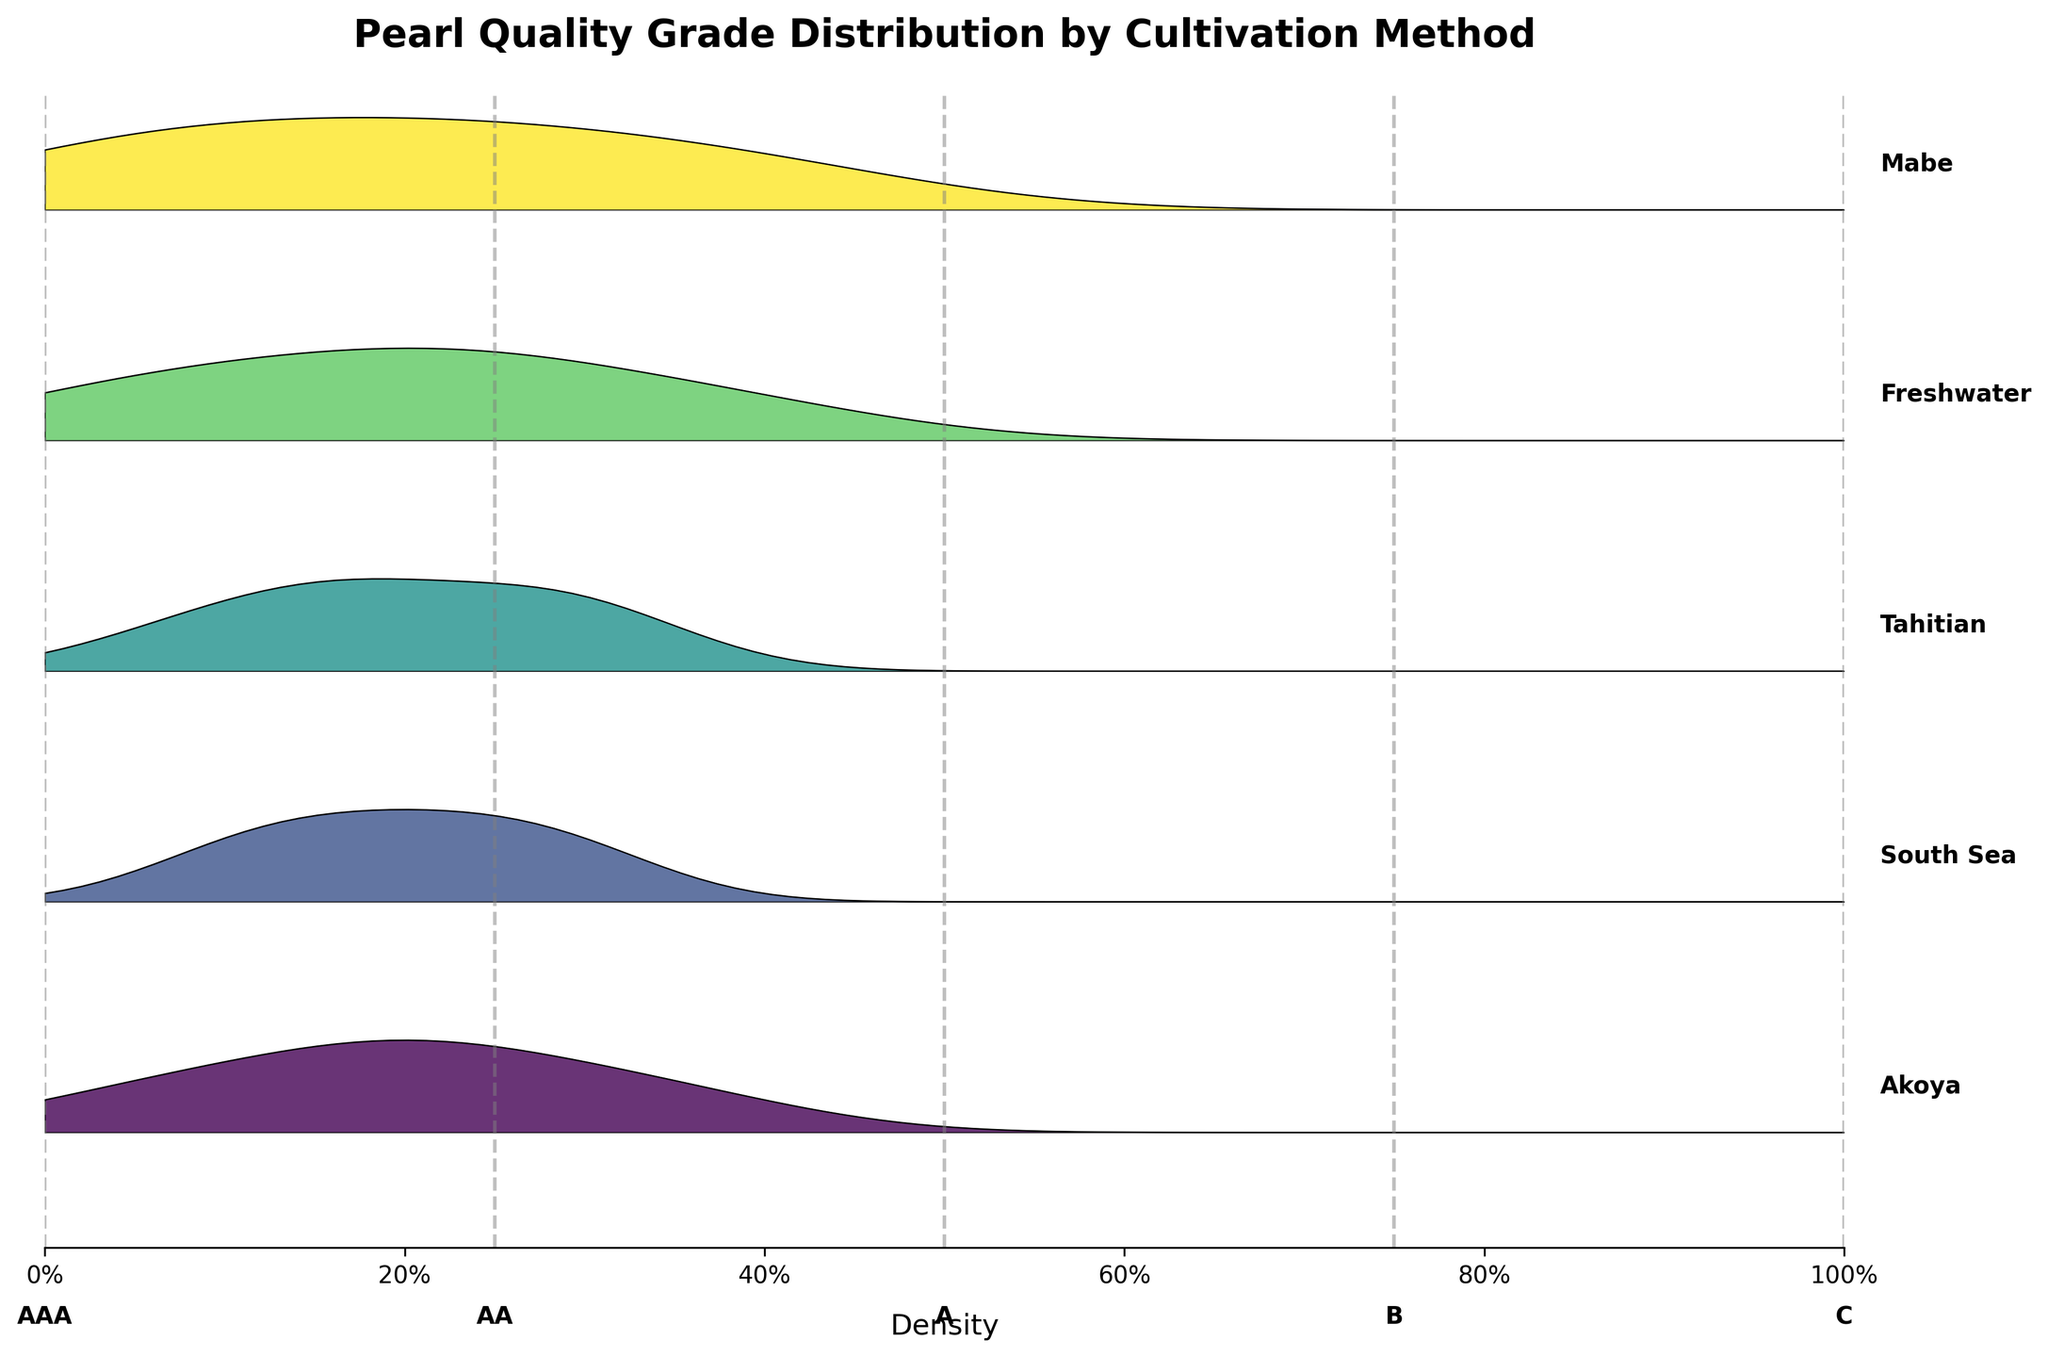How many different cultivation methods are displayed in the plot? Count the distinct labels corresponding to cultivation methods on the vertical axis text.
Answer: 5 Which cultivation method has the highest density for grade B pearls? Identify the highest peak on the Ridgeline plot for grade B, and check which cultivation method it's aligned with.
Answer: Mabe What is the maximum density value displayed on the x-axis? Look at the x-axis, the values range from 0 to 1.
Answer: 1 Which cultivation method shows the lowest density for grade AAA pearls? Locate the lowest peak or smallest area under the curve for grade AAA and identify the corresponding cultivation method.
Answer: Mabe Comparing Akoya and Tahitian, which has a higher density for grade A pearls? Examine the peaks for grade A pearls in both Akoya and Tahitian, then compare their heights.
Answer: Tahitian What’s the title of the plot? Read the text at the top of the plot, which usually describes the visualization.
Answer: Pearl Quality Grade Distribution by Cultivation Method Does Freshwater or South Sea have a higher density concentration for grade C pearls? Compare the heights of the peaks representing grade C pearls for Freshwater and South Sea.
Answer: Freshwater Between Akoya and Freshwater, which has a more uniform distribution across different grades? Look at the density curves for both methods and assess which has a similar height across all grades.
Answer: Akoya For which cultivation method does the density curve for grade B show the steepest increase? Identify the cultivation method where the slope of the density curve is steepest for grade B.
Answer: Mabe Which cultivation method covers the widest range of density values for grade A? Compare the spread of peaks at grade A across all cultivation methods to see which is the broadest.
Answer: Akoya 